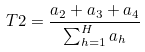Convert formula to latex. <formula><loc_0><loc_0><loc_500><loc_500>T 2 = \frac { a _ { 2 } + a _ { 3 } + a _ { 4 } } { \sum _ { h = 1 } ^ { H } a _ { h } }</formula> 